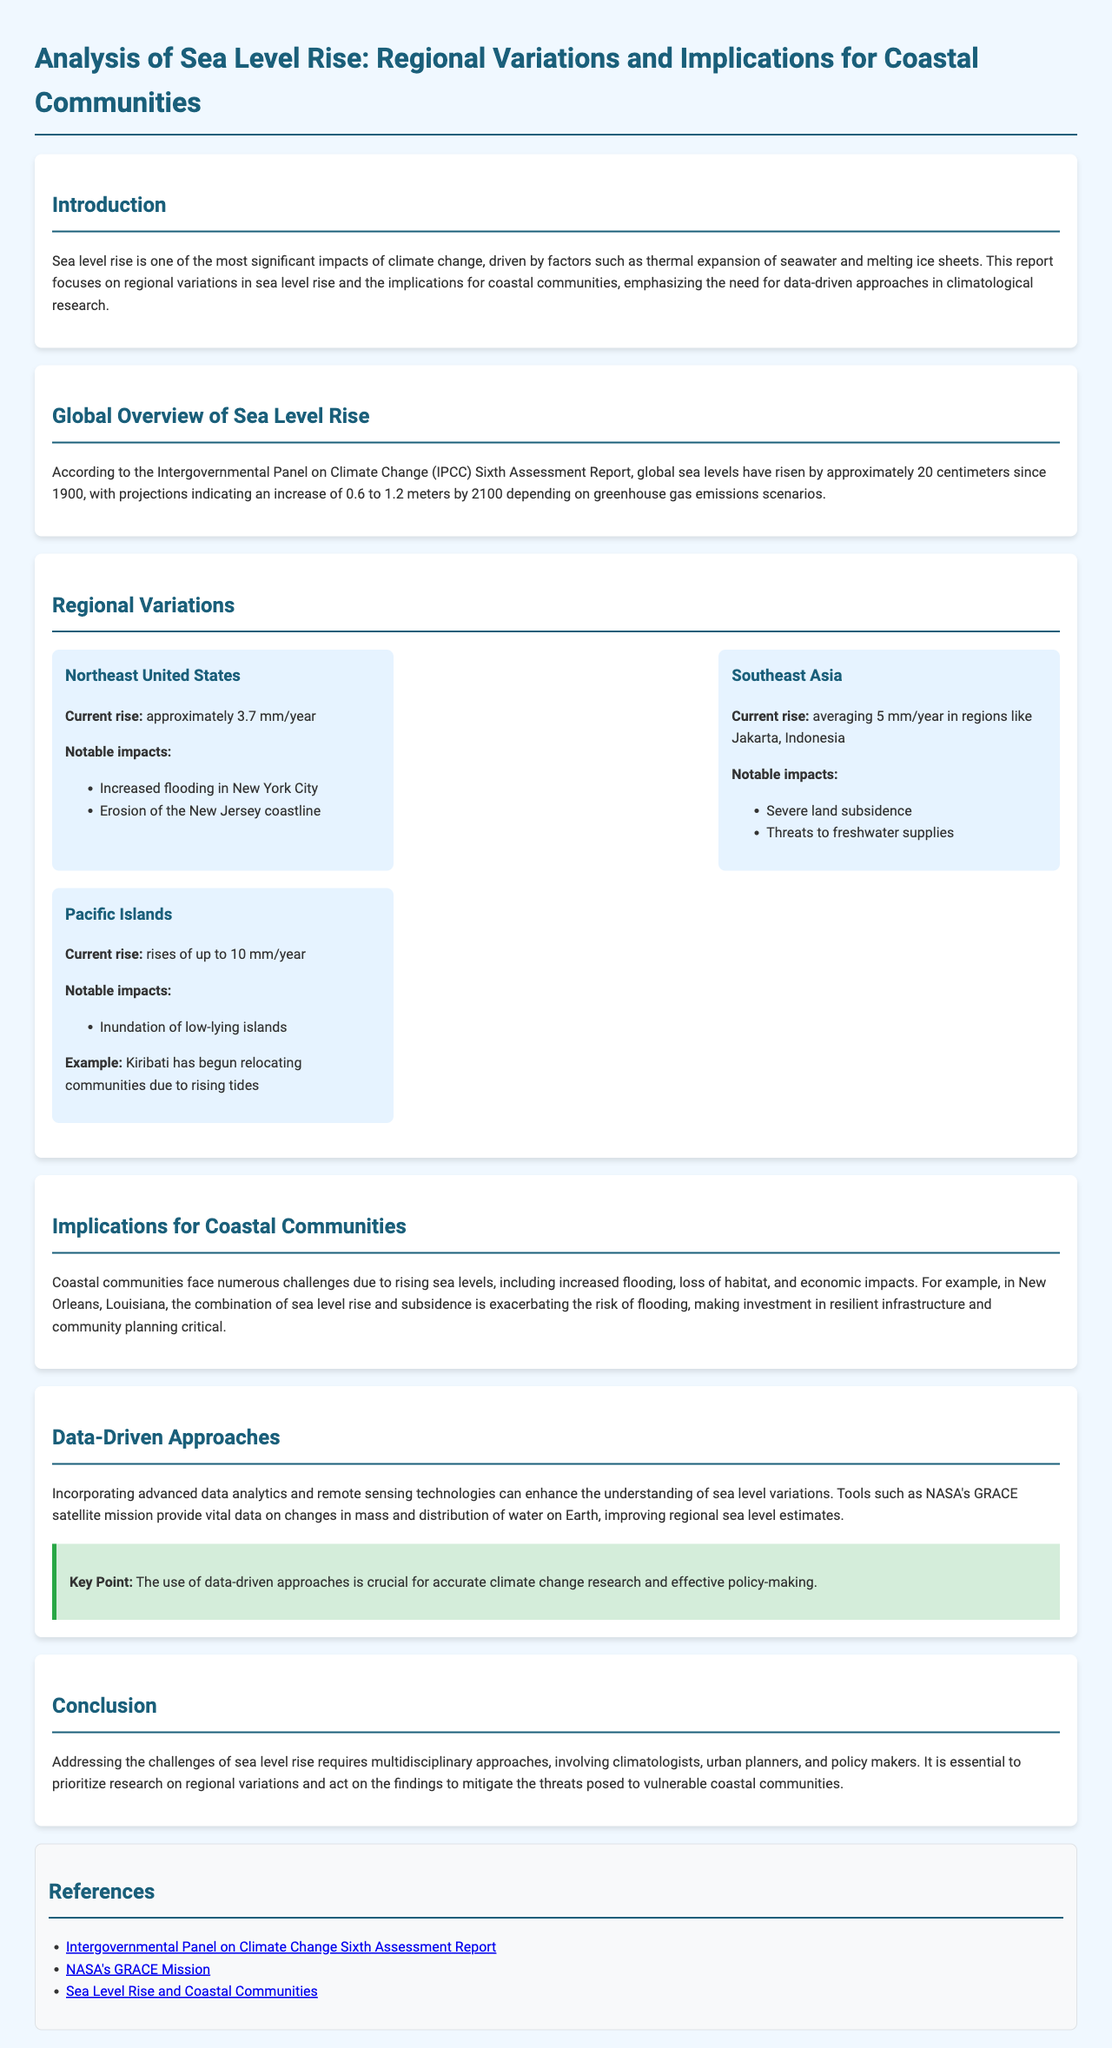What is the total rise of global sea levels since 1900? The document states that global sea levels have risen by approximately 20 centimeters since 1900.
Answer: 20 centimeters What is the current sea level rise rate in the Northeast United States? The report mentions that the current rise in the Northeast United States is approximately 3.7 mm/year.
Answer: 3.7 mm/year Which region is experiencing the highest current rise in sea level? The document highlights that the Pacific Islands are experiencing rises of up to 10 mm/year.
Answer: Pacific Islands What are the notable impacts of sea level rise in Jakarta, Indonesia? The report lists severe land subsidence and threats to freshwater supplies as notable impacts.
Answer: Severe land subsidence, threats to freshwater supplies Which mission provides vital data on changes in mass and distribution of water on Earth? The document refers to NASA's GRACE satellite mission as providing vital data.
Answer: NASA's GRACE Mission Why is it critical to invest in resilient infrastructure in New Orleans? The document explains that the combination of sea level rise and subsidence is exacerbating the risk of flooding in New Orleans, making investment critical.
Answer: Exacerbating the risk of flooding What kind of approaches does the report emphasize for managing sea level rise? The report emphasizes multidisciplinary approaches involving climatologists, urban planners, and policy makers.
Answer: Multidisciplinary approaches What is the projected increase in sea levels by 2100 according to IPCC scenarios? The document states that projections indicate an increase of 0.6 to 1.2 meters by 2100.
Answer: 0.6 to 1.2 meters 